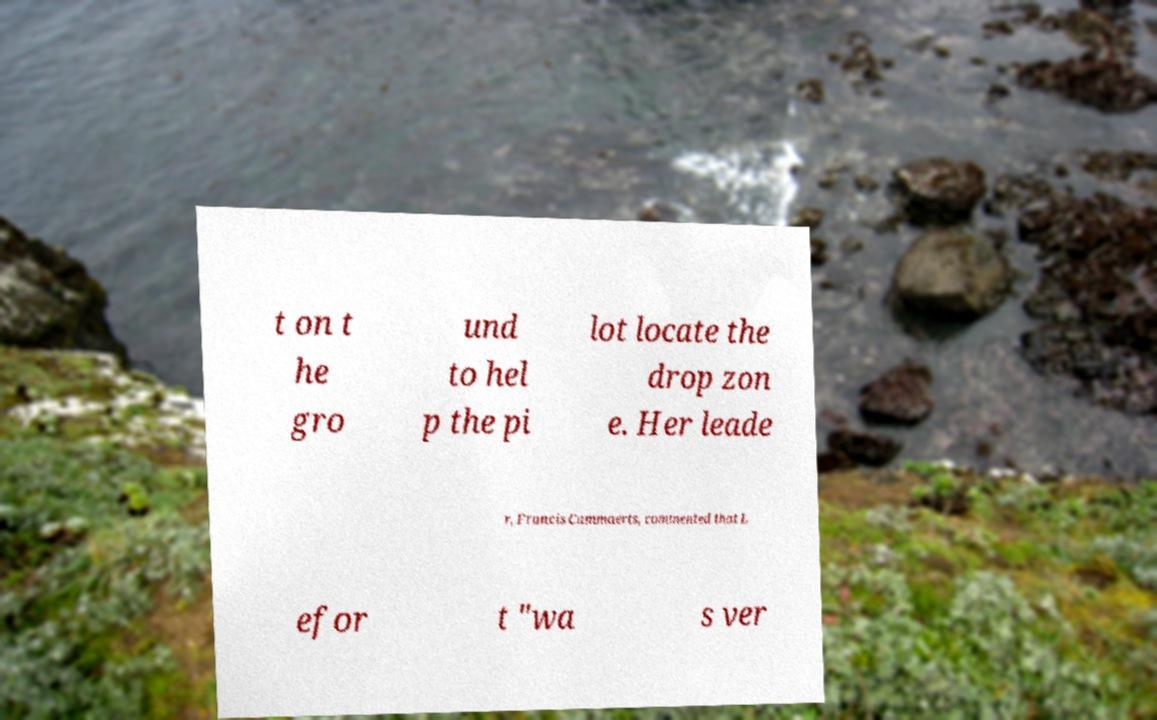Please identify and transcribe the text found in this image. t on t he gro und to hel p the pi lot locate the drop zon e. Her leade r, Francis Cammaerts, commented that L efor t "wa s ver 